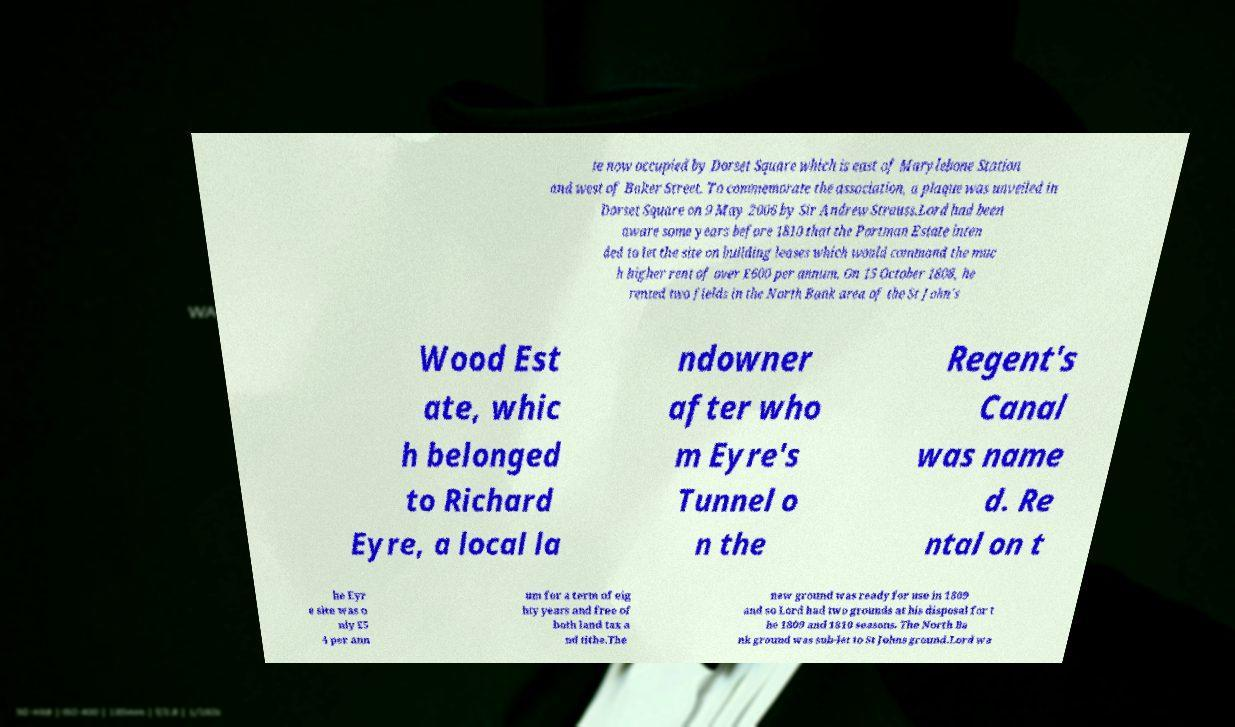Could you assist in decoding the text presented in this image and type it out clearly? te now occupied by Dorset Square which is east of Marylebone Station and west of Baker Street. To commemorate the association, a plaque was unveiled in Dorset Square on 9 May 2006 by Sir Andrew Strauss.Lord had been aware some years before 1810 that the Portman Estate inten ded to let the site on building leases which would command the muc h higher rent of over £600 per annum. On 15 October 1808, he rented two fields in the North Bank area of the St John's Wood Est ate, whic h belonged to Richard Eyre, a local la ndowner after who m Eyre's Tunnel o n the Regent's Canal was name d. Re ntal on t he Eyr e site was o nly £5 4 per ann um for a term of eig hty years and free of both land tax a nd tithe.The new ground was ready for use in 1809 and so Lord had two grounds at his disposal for t he 1809 and 1810 seasons. The North Ba nk ground was sub-let to St Johns ground.Lord wa 